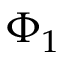Convert formula to latex. <formula><loc_0><loc_0><loc_500><loc_500>\Phi _ { 1 }</formula> 